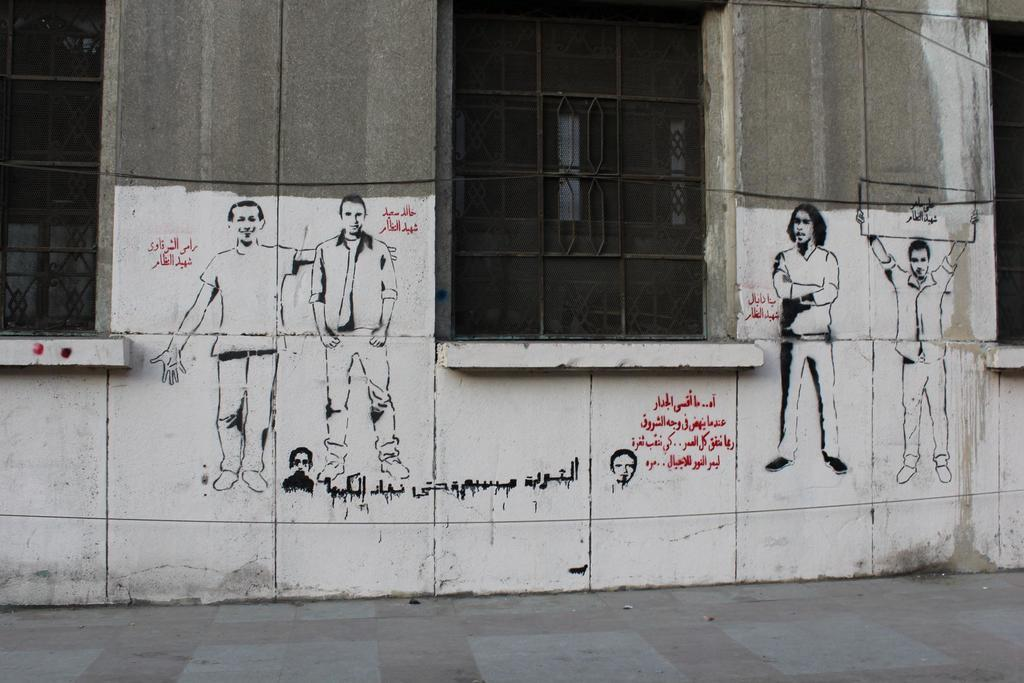What is a prominent feature in the image? There is a wall in the image. What can be seen on the wall? The wall has windows and a painting of people. Are there any words on the wall? Yes, there are words on the wall. How many noses can be seen in the painting of people on the wall? There is no mention of noses in the image, as the provided facts only mention a painting of people. 